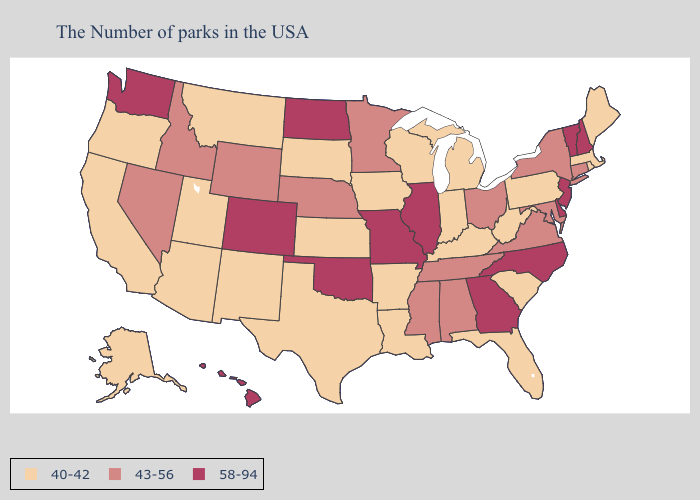Does the map have missing data?
Concise answer only. No. What is the highest value in the Northeast ?
Write a very short answer. 58-94. Which states have the highest value in the USA?
Concise answer only. New Hampshire, Vermont, New Jersey, Delaware, North Carolina, Georgia, Illinois, Missouri, Oklahoma, North Dakota, Colorado, Washington, Hawaii. Name the states that have a value in the range 43-56?
Be succinct. Connecticut, New York, Maryland, Virginia, Ohio, Alabama, Tennessee, Mississippi, Minnesota, Nebraska, Wyoming, Idaho, Nevada. Which states have the lowest value in the South?
Be succinct. South Carolina, West Virginia, Florida, Kentucky, Louisiana, Arkansas, Texas. Does Louisiana have the highest value in the South?
Answer briefly. No. Name the states that have a value in the range 43-56?
Quick response, please. Connecticut, New York, Maryland, Virginia, Ohio, Alabama, Tennessee, Mississippi, Minnesota, Nebraska, Wyoming, Idaho, Nevada. Name the states that have a value in the range 58-94?
Write a very short answer. New Hampshire, Vermont, New Jersey, Delaware, North Carolina, Georgia, Illinois, Missouri, Oklahoma, North Dakota, Colorado, Washington, Hawaii. Name the states that have a value in the range 58-94?
Short answer required. New Hampshire, Vermont, New Jersey, Delaware, North Carolina, Georgia, Illinois, Missouri, Oklahoma, North Dakota, Colorado, Washington, Hawaii. What is the value of Indiana?
Answer briefly. 40-42. What is the lowest value in states that border South Dakota?
Answer briefly. 40-42. What is the lowest value in the USA?
Write a very short answer. 40-42. Name the states that have a value in the range 43-56?
Keep it brief. Connecticut, New York, Maryland, Virginia, Ohio, Alabama, Tennessee, Mississippi, Minnesota, Nebraska, Wyoming, Idaho, Nevada. What is the lowest value in the USA?
Concise answer only. 40-42. What is the value of South Dakota?
Short answer required. 40-42. 